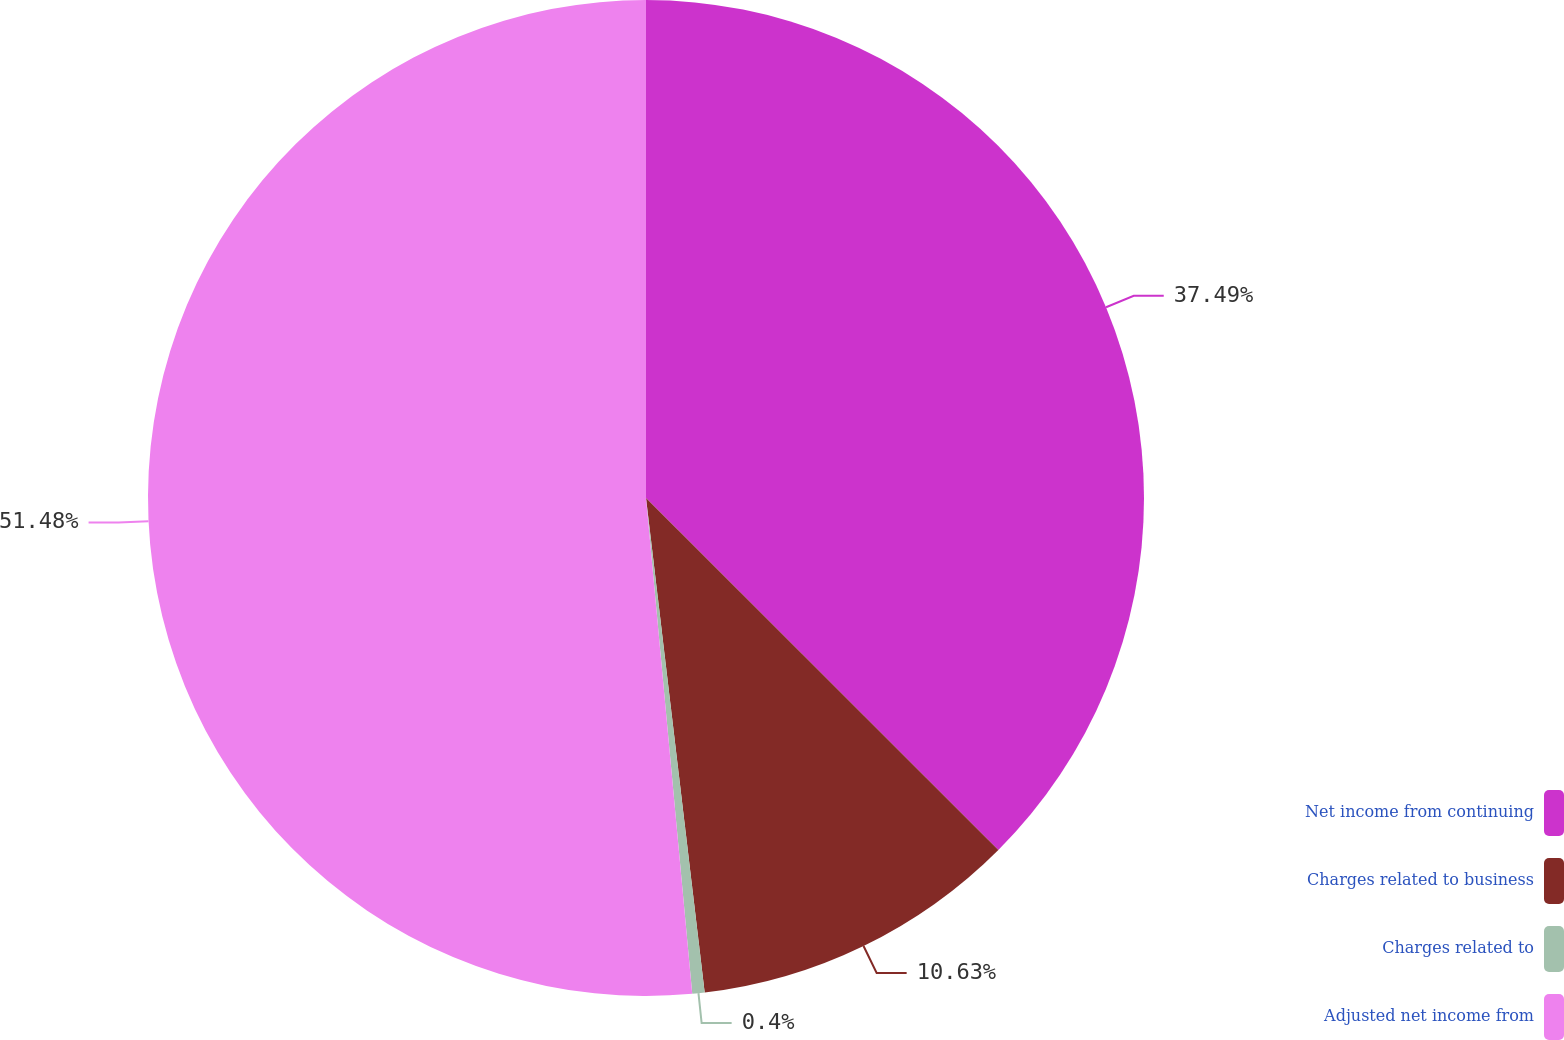Convert chart. <chart><loc_0><loc_0><loc_500><loc_500><pie_chart><fcel>Net income from continuing<fcel>Charges related to business<fcel>Charges related to<fcel>Adjusted net income from<nl><fcel>37.49%<fcel>10.63%<fcel>0.4%<fcel>51.48%<nl></chart> 